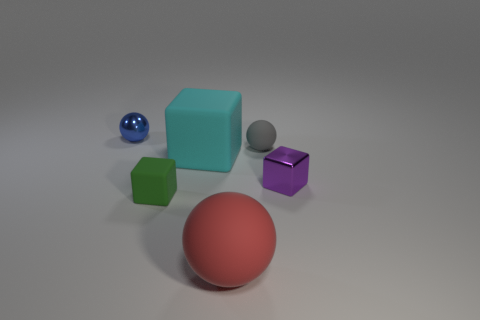Are there any patterns or textures visible on the surface of these objects? The objects in the image largely have solid colors without intricate patterns or textures. Their surfaces range from smooth and shiny to matte and slightly diffuse. The variety of surface appearances adds depth to the scene and showcases different material properties, like reflectivity and texture. Which object stands out the most to you in this image and why? The small purple cube stands out prominently due to its vibrant color and shiny surface, which contrasts with the more subdued colors and matte finishes of other objects in the image. Its reflective property captures attention by drawing the eye toward the light and color reflected on its surface. 